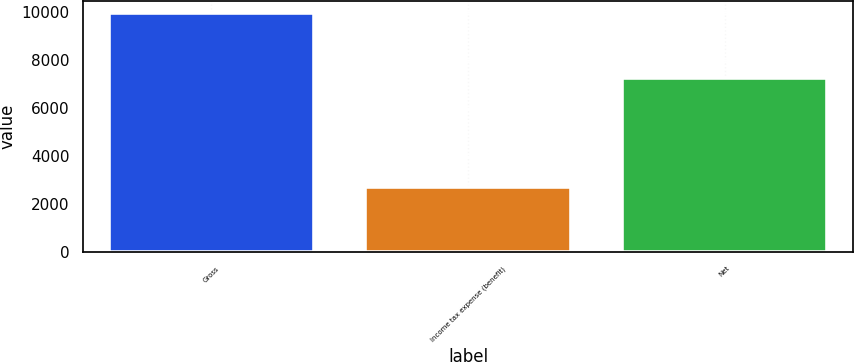<chart> <loc_0><loc_0><loc_500><loc_500><bar_chart><fcel>Gross<fcel>Income tax expense (benefit)<fcel>Net<nl><fcel>9936<fcel>2695<fcel>7241<nl></chart> 